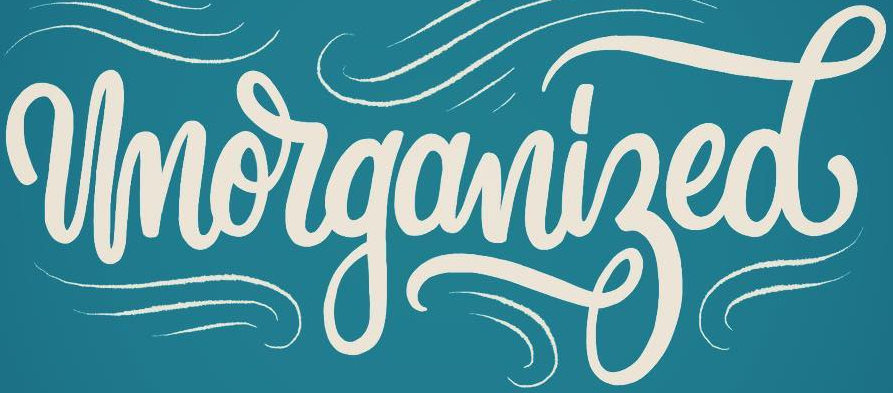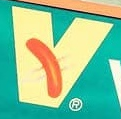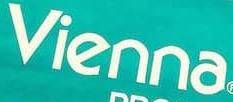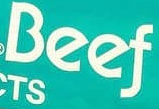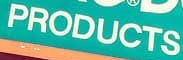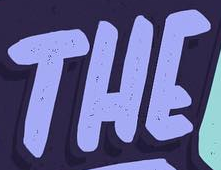What text appears in these images from left to right, separated by a semicolon? Unorganized; v; vienna; Beef; PRODUCTS; THE 